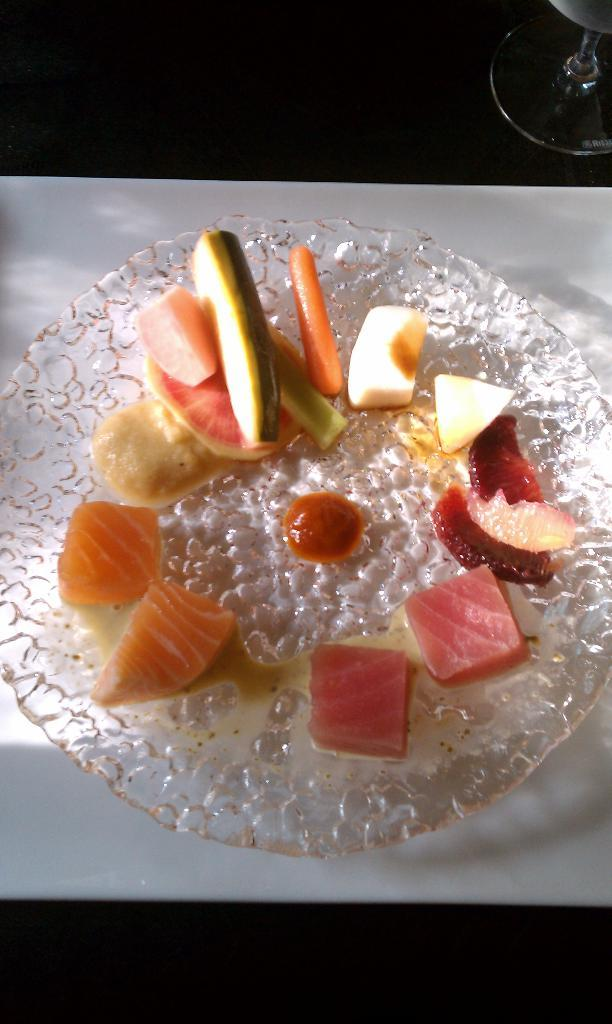What type of food is visible in the image? There are chopped fruits in the image. What is the chopped fruit placed on? The chopped fruits are on a glass plate. What color is the surface beneath the glass plate? The glass plate is on a white surface. Can you describe any other glass objects in the image? There is a glass visible in the top right of the image. What type of line can be seen connecting the chopped fruits to the squirrel in the image? There is no squirrel or line connecting the chopped fruits to any object in the image. 